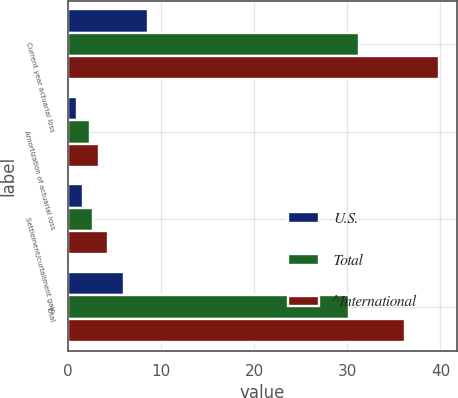Convert chart. <chart><loc_0><loc_0><loc_500><loc_500><stacked_bar_chart><ecel><fcel>Current year actuarial loss<fcel>Amortization of actuarial loss<fcel>Settlement/curtailment gain<fcel>Total<nl><fcel>U.S.<fcel>8.6<fcel>0.9<fcel>1.6<fcel>6<nl><fcel>Total<fcel>31.2<fcel>2.4<fcel>2.7<fcel>30.2<nl><fcel>^International<fcel>39.8<fcel>3.3<fcel>4.3<fcel>36.2<nl></chart> 